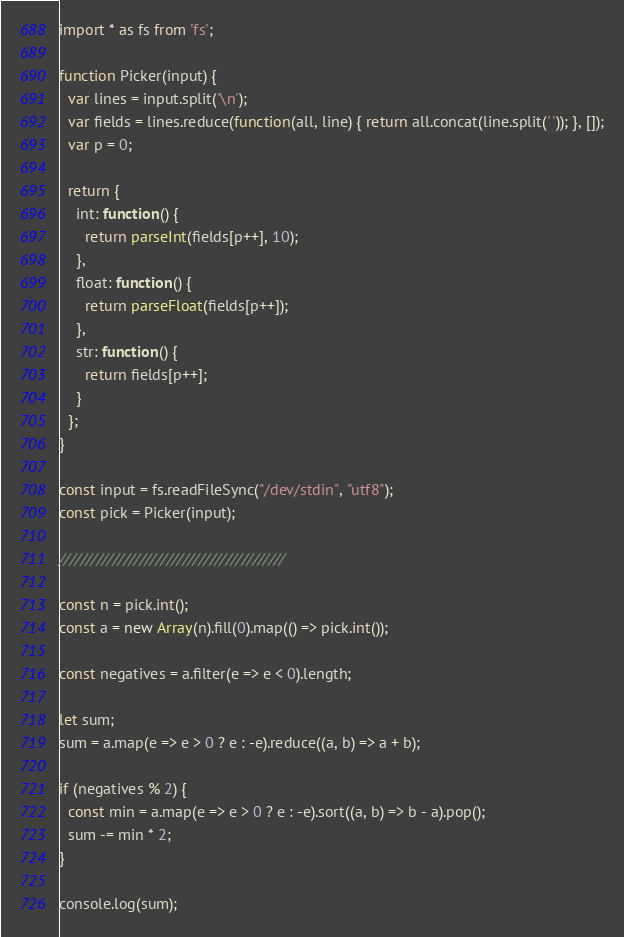Convert code to text. <code><loc_0><loc_0><loc_500><loc_500><_TypeScript_>import * as fs from 'fs';

function Picker(input) {
  var lines = input.split('\n');
  var fields = lines.reduce(function(all, line) { return all.concat(line.split(' ')); }, []);
  var p = 0;

  return {
    int: function() {
      return parseInt(fields[p++], 10);
    },
    float: function() {
      return parseFloat(fields[p++]);
    },
    str: function() {
      return fields[p++];
    }
  };
}

const input = fs.readFileSync("/dev/stdin", "utf8");
const pick = Picker(input);

//////////////////////////////////////////

const n = pick.int();
const a = new Array(n).fill(0).map(() => pick.int());

const negatives = a.filter(e => e < 0).length;

let sum;
sum = a.map(e => e > 0 ? e : -e).reduce((a, b) => a + b);

if (negatives % 2) {
  const min = a.map(e => e > 0 ? e : -e).sort((a, b) => b - a).pop();
  sum -= min * 2;
}

console.log(sum);</code> 